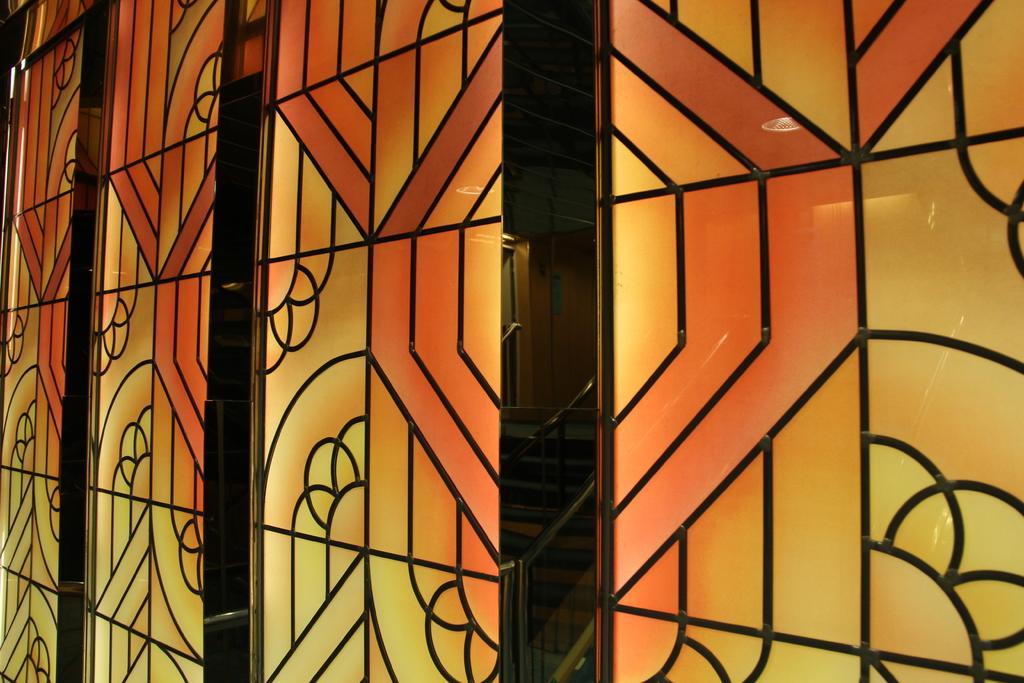Describe this image in one or two sentences. In this image I can see the orange colour wall, I can also see yellow colour on this wall. 